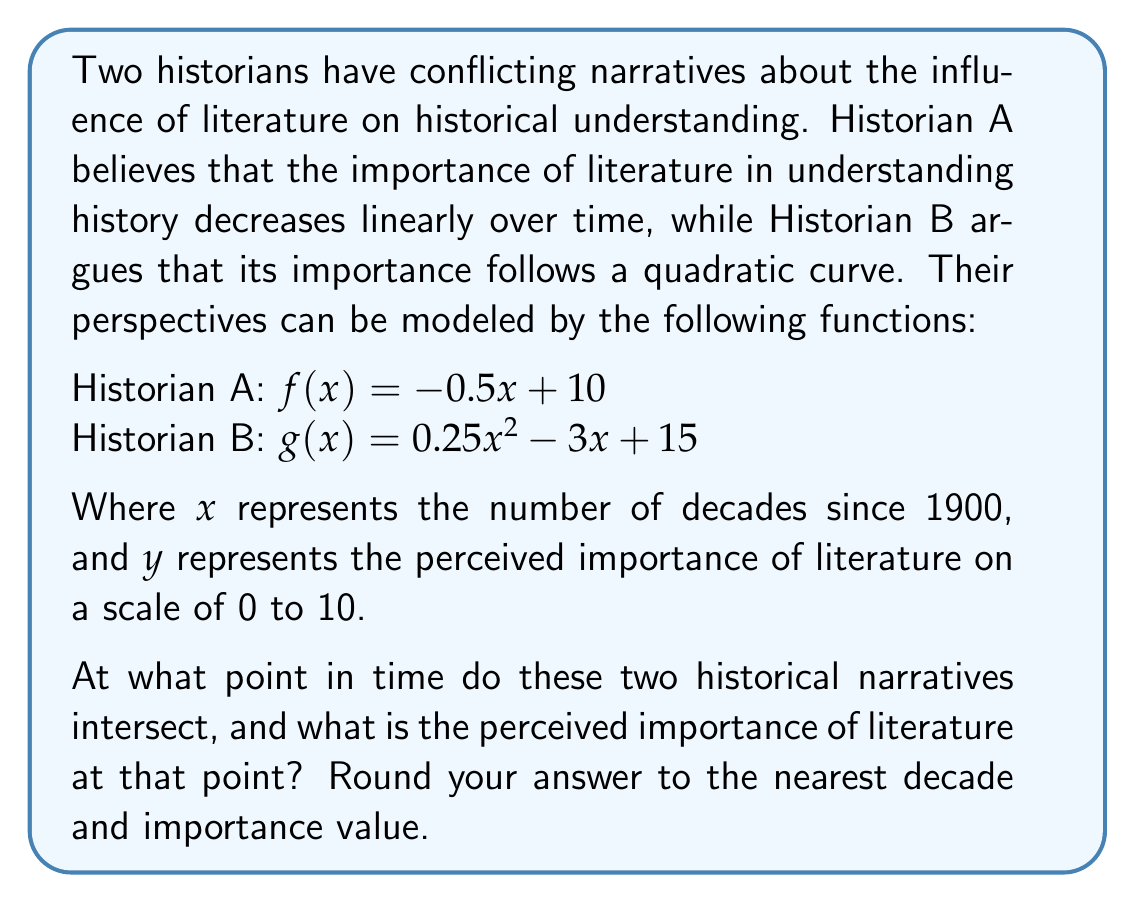Can you answer this question? To find the intersection point of these two functions, we need to solve the equation:

$f(x) = g(x)$

Substituting the given functions:

$-0.5x + 10 = 0.25x^2 - 3x + 15$

Rearranging the equation:

$0.25x^2 - 2.5x + 5 = 0$

This is a quadratic equation in the form $ax^2 + bx + c = 0$, where:
$a = 0.25$
$b = -2.5$
$c = 5$

We can solve this using the quadratic formula: $x = \frac{-b \pm \sqrt{b^2 - 4ac}}{2a}$

Substituting the values:

$x = \frac{2.5 \pm \sqrt{(-2.5)^2 - 4(0.25)(5)}}{2(0.25)}$

$x = \frac{2.5 \pm \sqrt{6.25 - 5}}{0.5}$

$x = \frac{2.5 \pm \sqrt{1.25}}{0.5}$

$x = \frac{2.5 \pm 1.118}{0.5}$

This gives us two solutions:

$x_1 = \frac{2.5 + 1.118}{0.5} = 7.236$
$x_2 = \frac{2.5 - 1.118}{0.5} = 2.764$

Since $x$ represents decades since 1900, the positive solution $x_1 = 7.236$ is the relevant one. Rounding to the nearest decade, we get 7 decades since 1900, which corresponds to the year 1970.

To find the perceived importance at this point, we can substitute $x = 7.236$ into either function:

$f(7.236) = -0.5(7.236) + 10 = 6.382$

Rounding to the nearest importance value, we get 6.
Answer: The two historical narratives intersect around 1970, with a perceived importance of literature of approximately 6 on a scale of 0 to 10. 